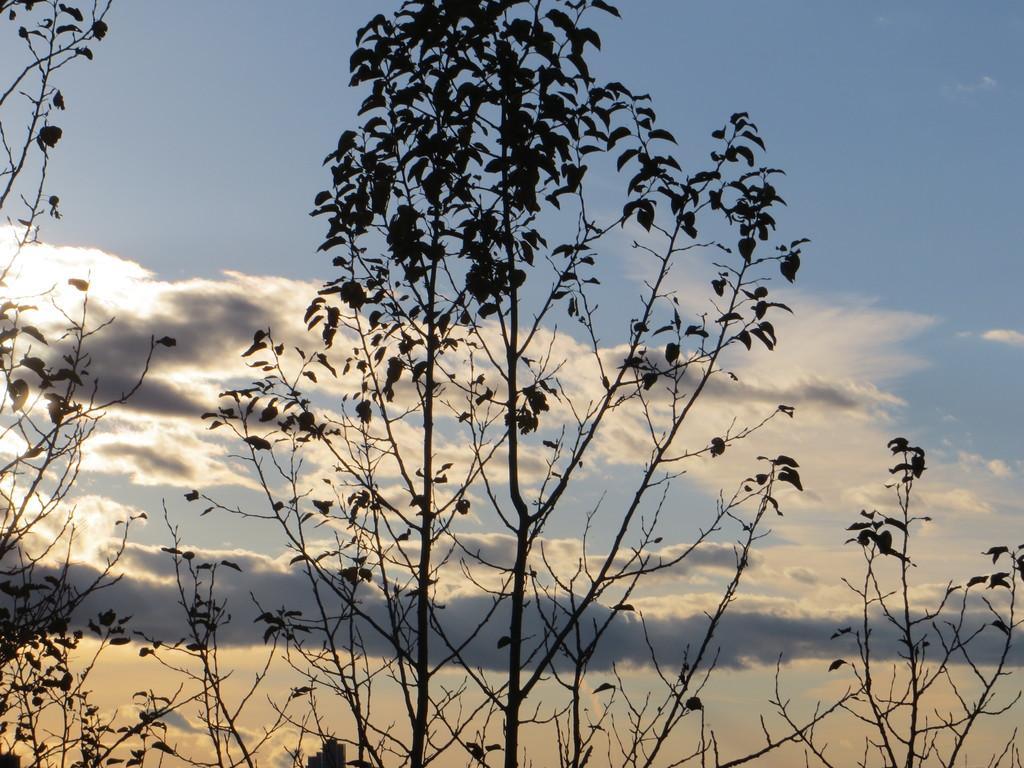How would you summarize this image in a sentence or two? This image consists of trees. In the background, there are clouds in the sky. 